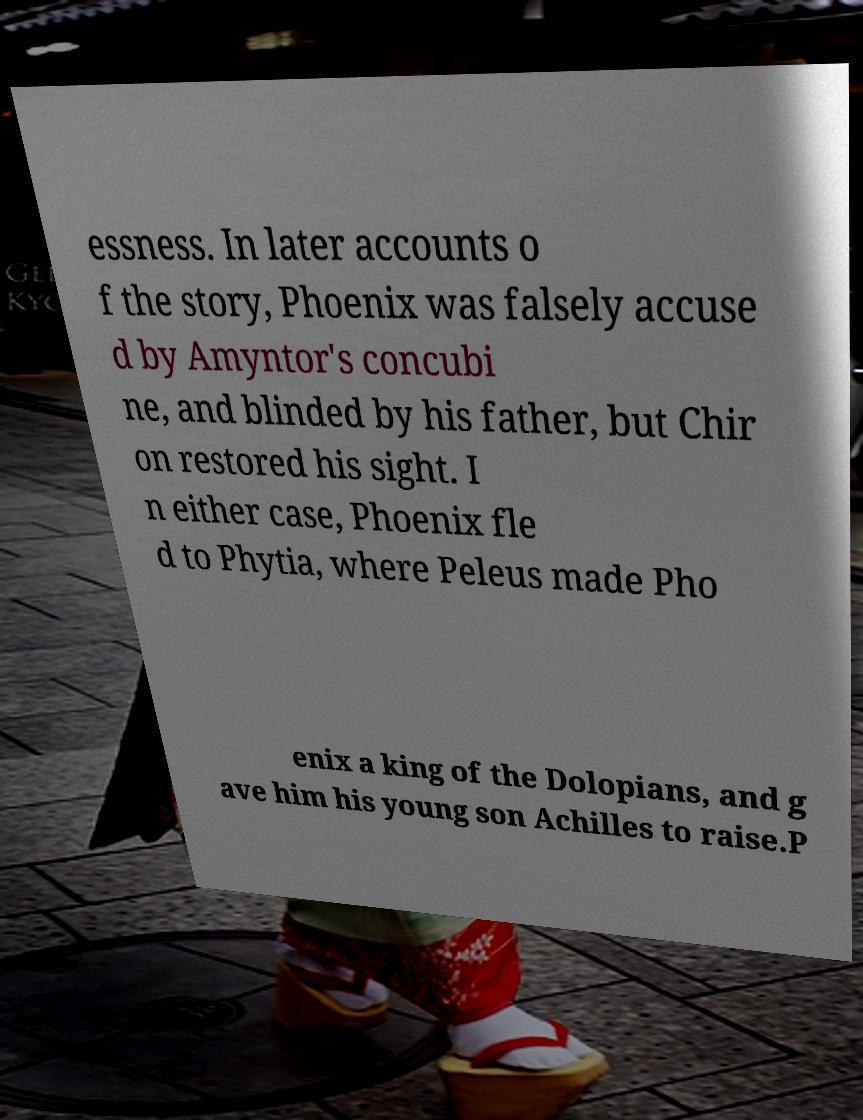There's text embedded in this image that I need extracted. Can you transcribe it verbatim? essness. In later accounts o f the story, Phoenix was falsely accuse d by Amyntor's concubi ne, and blinded by his father, but Chir on restored his sight. I n either case, Phoenix fle d to Phytia, where Peleus made Pho enix a king of the Dolopians, and g ave him his young son Achilles to raise.P 